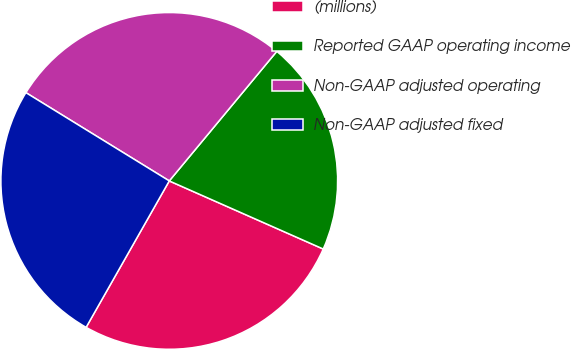<chart> <loc_0><loc_0><loc_500><loc_500><pie_chart><fcel>(millions)<fcel>Reported GAAP operating income<fcel>Non-GAAP adjusted operating<fcel>Non-GAAP adjusted fixed<nl><fcel>26.59%<fcel>20.6%<fcel>27.24%<fcel>25.56%<nl></chart> 